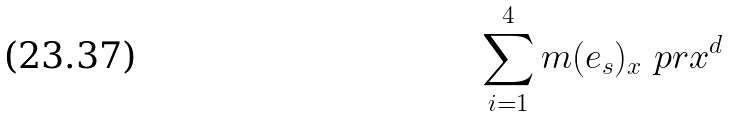<formula> <loc_0><loc_0><loc_500><loc_500>\sum _ { i = 1 } ^ { 4 } m ( e _ { s } ) _ { x } \ p r { x ^ { d } }</formula> 